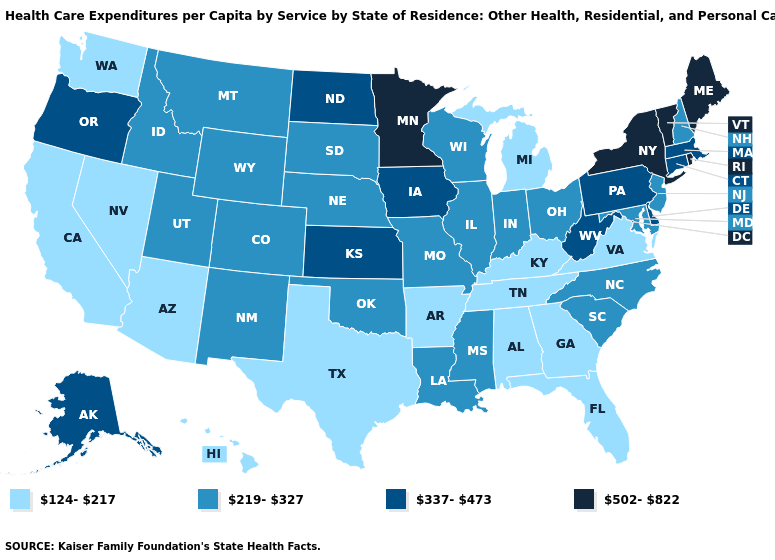Which states hav the highest value in the West?
Be succinct. Alaska, Oregon. Which states have the lowest value in the MidWest?
Write a very short answer. Michigan. What is the value of Illinois?
Short answer required. 219-327. What is the value of New Mexico?
Quick response, please. 219-327. Does Washington have a lower value than Wyoming?
Give a very brief answer. Yes. Does Arizona have a higher value than New Jersey?
Short answer required. No. What is the lowest value in the West?
Short answer required. 124-217. What is the value of Hawaii?
Concise answer only. 124-217. Does Florida have a higher value than Mississippi?
Quick response, please. No. What is the highest value in the USA?
Write a very short answer. 502-822. Name the states that have a value in the range 502-822?
Give a very brief answer. Maine, Minnesota, New York, Rhode Island, Vermont. Does Alaska have the highest value in the West?
Write a very short answer. Yes. What is the highest value in states that border West Virginia?
Short answer required. 337-473. Does North Dakota have a lower value than Arizona?
Concise answer only. No. 